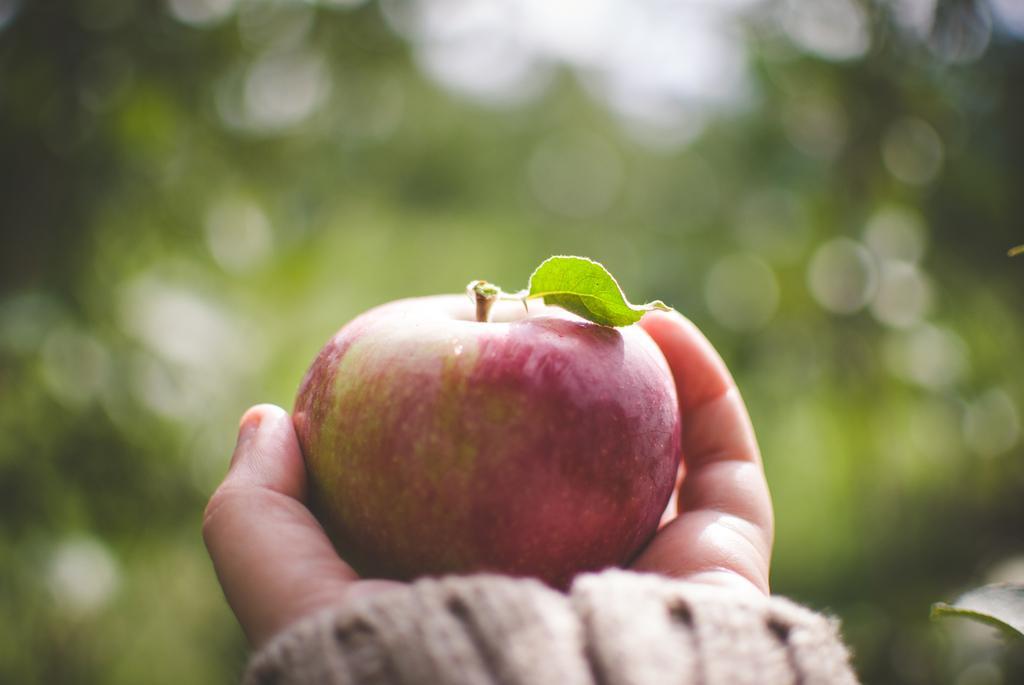What can be seen in the image that belongs to a person? There is a person's hand in the image. What is the hand holding? The hand is holding an apple. Can you describe the background of the image? The background of the image is blurred. How many chickens are visible in the image? There are no chickens present in the image. What type of drink is being served in the image? There is no drink present in the image, and the topic of eggnog is not relevant to the image. 